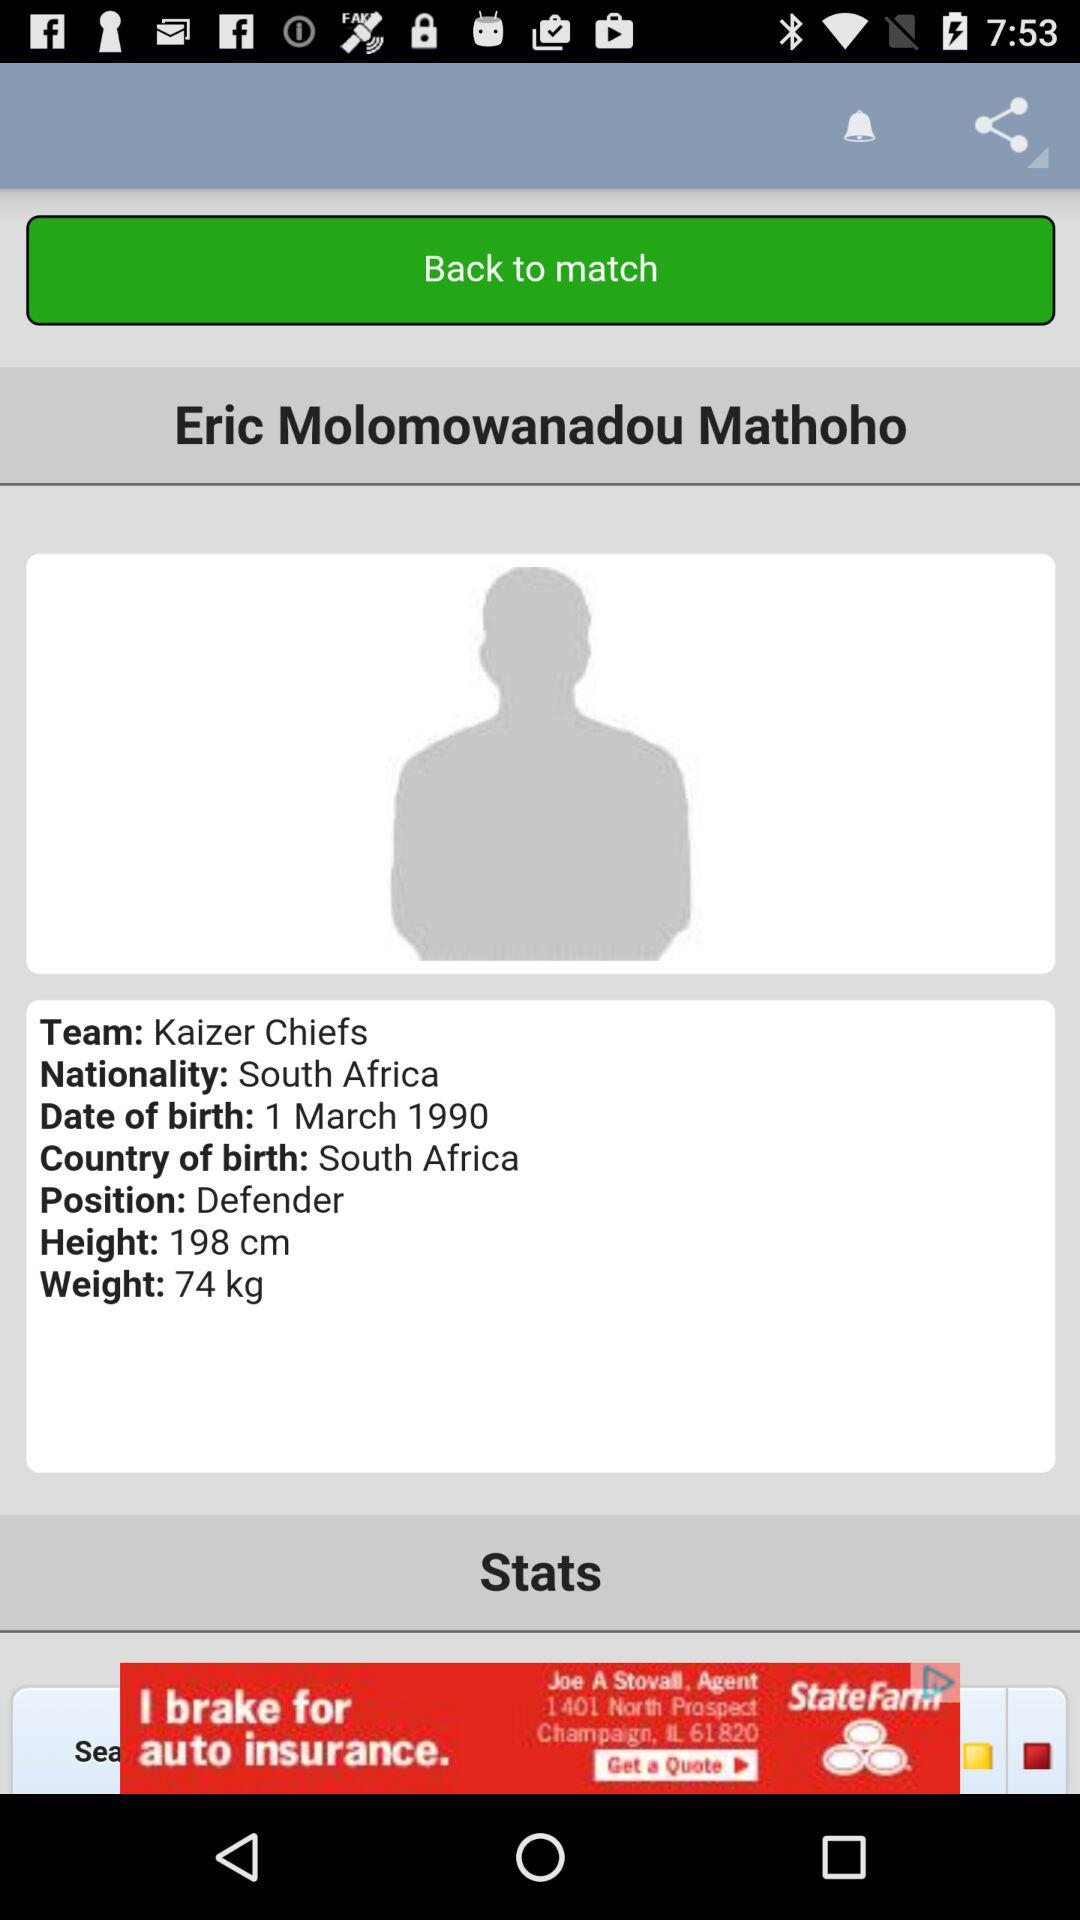How many more centimeters tall is Eric Molomowanadou Mathoho than he is wide?
Answer the question using a single word or phrase. 124 